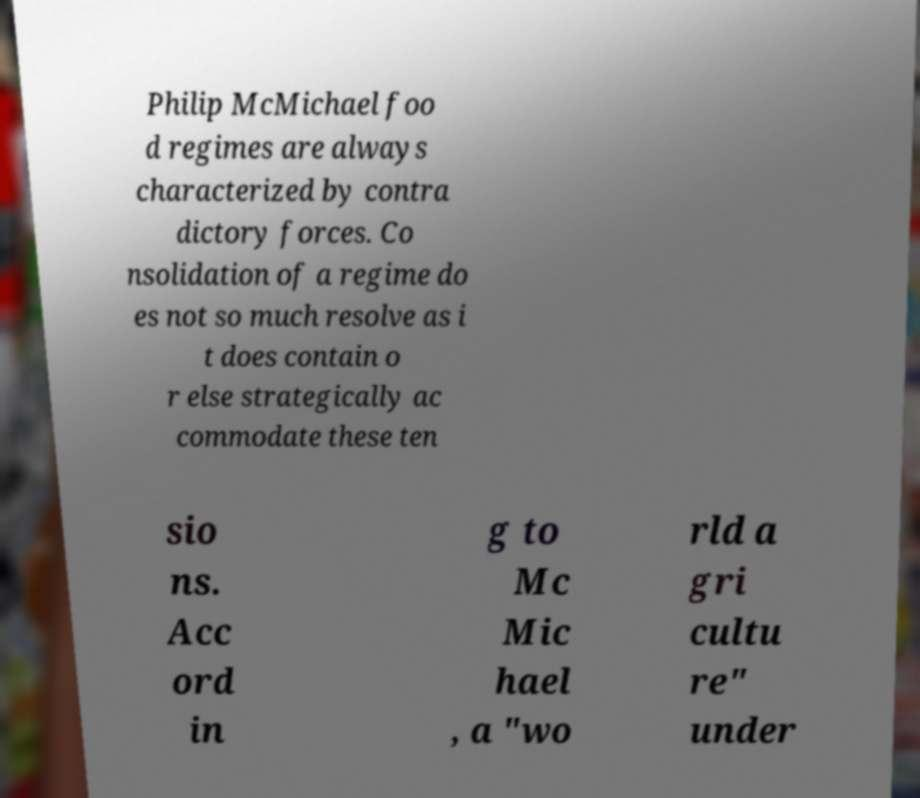Could you assist in decoding the text presented in this image and type it out clearly? Philip McMichael foo d regimes are always characterized by contra dictory forces. Co nsolidation of a regime do es not so much resolve as i t does contain o r else strategically ac commodate these ten sio ns. Acc ord in g to Mc Mic hael , a "wo rld a gri cultu re" under 